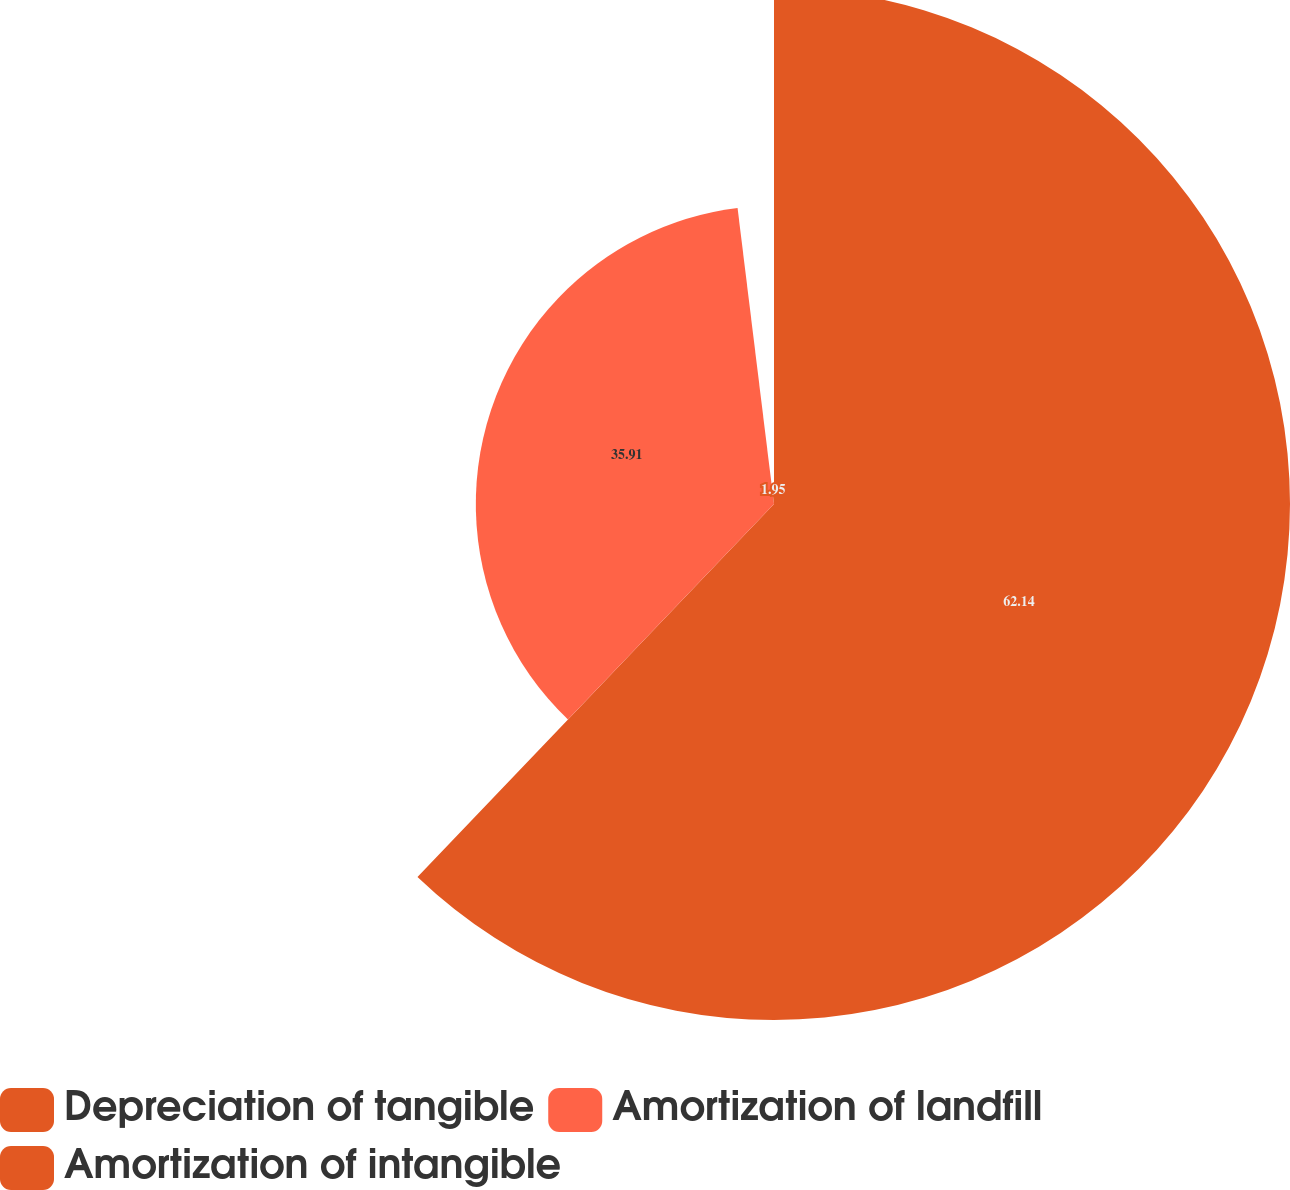<chart> <loc_0><loc_0><loc_500><loc_500><pie_chart><fcel>Depreciation of tangible<fcel>Amortization of landfill<fcel>Amortization of intangible<nl><fcel>62.14%<fcel>35.91%<fcel>1.95%<nl></chart> 